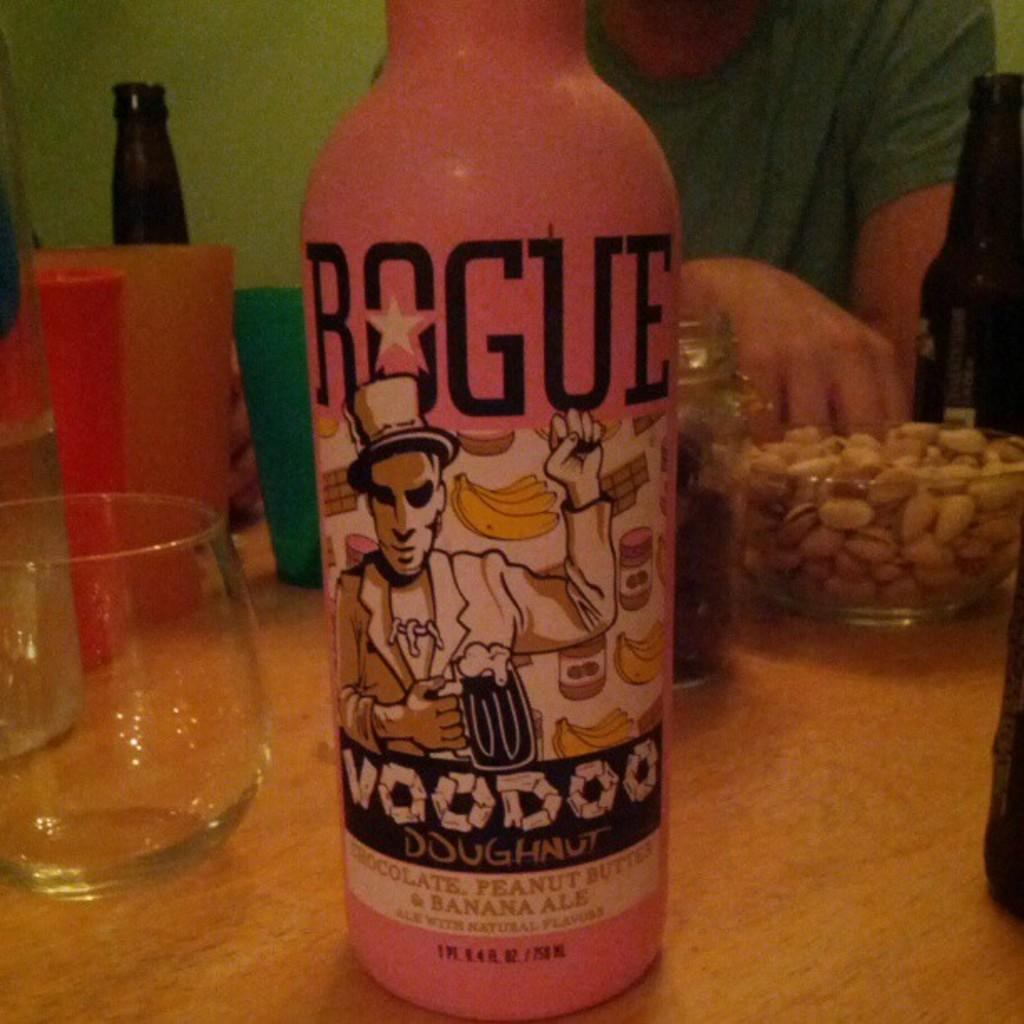<image>
Create a compact narrative representing the image presented. a close up of a pink Rogue Voodoo Ale 